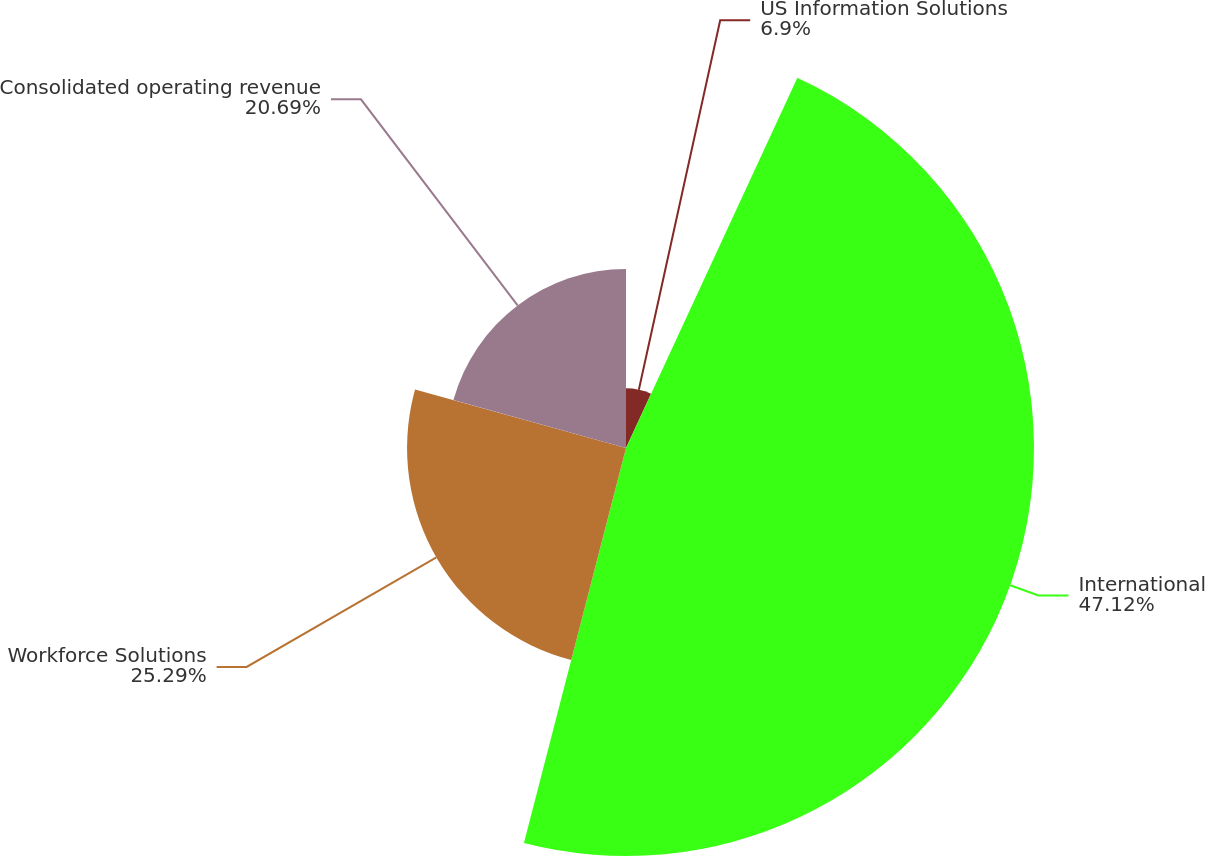Convert chart. <chart><loc_0><loc_0><loc_500><loc_500><pie_chart><fcel>US Information Solutions<fcel>International<fcel>Workforce Solutions<fcel>Consolidated operating revenue<nl><fcel>6.9%<fcel>47.13%<fcel>25.29%<fcel>20.69%<nl></chart> 